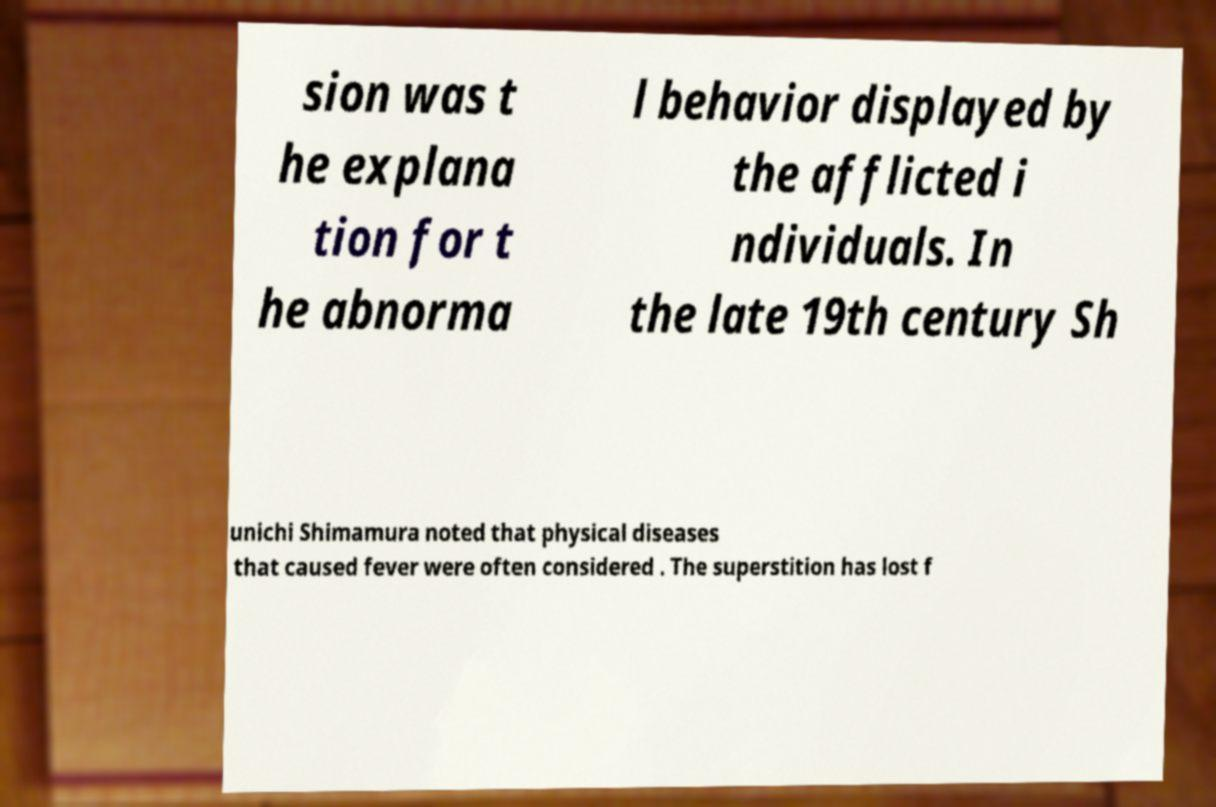Can you accurately transcribe the text from the provided image for me? sion was t he explana tion for t he abnorma l behavior displayed by the afflicted i ndividuals. In the late 19th century Sh unichi Shimamura noted that physical diseases that caused fever were often considered . The superstition has lost f 